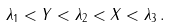<formula> <loc_0><loc_0><loc_500><loc_500>\lambda _ { 1 } < Y < \lambda _ { 2 } < X < \lambda _ { 3 } \, .</formula> 